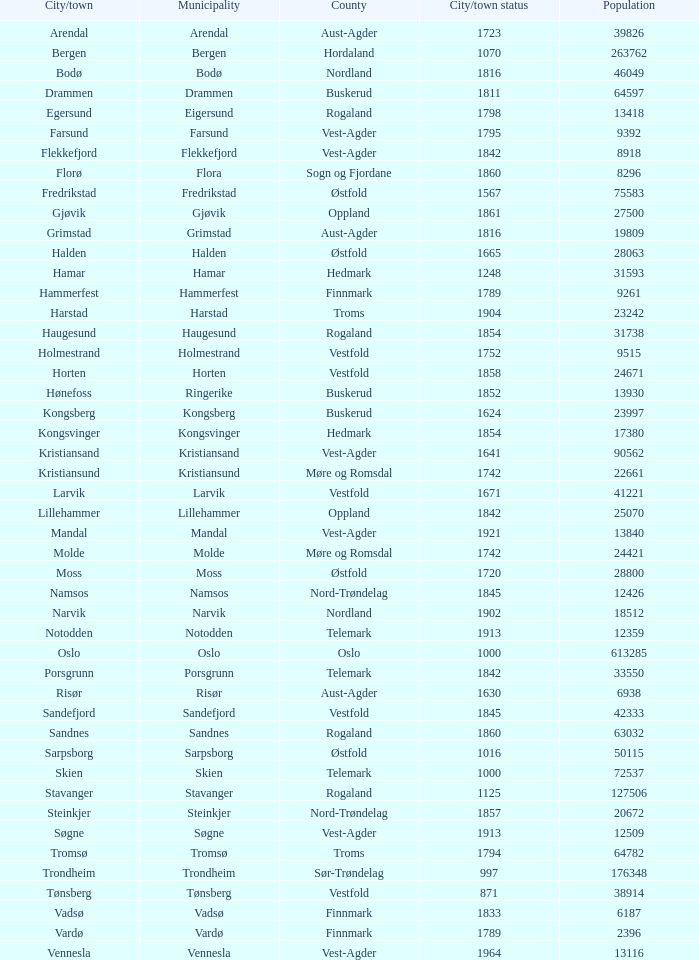In which county can the town of halden be found? Østfold. 